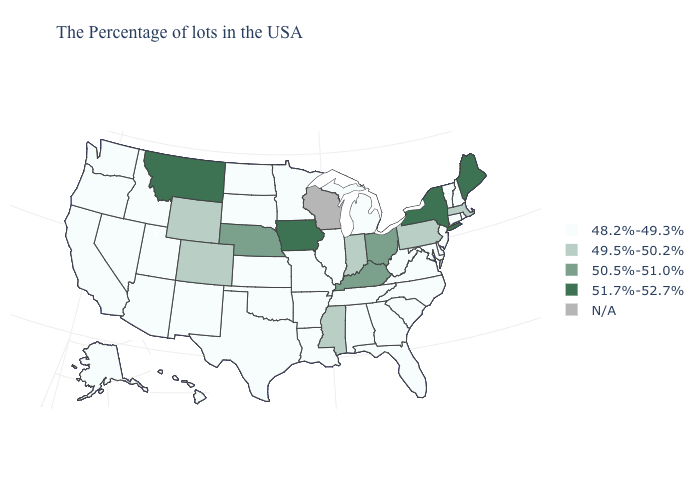Which states have the lowest value in the MidWest?
Keep it brief. Michigan, Illinois, Missouri, Minnesota, Kansas, South Dakota, North Dakota. What is the value of South Dakota?
Be succinct. 48.2%-49.3%. What is the lowest value in states that border Louisiana?
Be succinct. 48.2%-49.3%. Which states have the lowest value in the West?
Keep it brief. New Mexico, Utah, Arizona, Idaho, Nevada, California, Washington, Oregon, Alaska, Hawaii. What is the lowest value in the West?
Concise answer only. 48.2%-49.3%. What is the lowest value in states that border Arkansas?
Keep it brief. 48.2%-49.3%. What is the value of Minnesota?
Short answer required. 48.2%-49.3%. Does Iowa have the highest value in the MidWest?
Write a very short answer. Yes. What is the value of Kentucky?
Answer briefly. 50.5%-51.0%. Does the map have missing data?
Write a very short answer. Yes. What is the value of Illinois?
Quick response, please. 48.2%-49.3%. Among the states that border Minnesota , does Iowa have the highest value?
Quick response, please. Yes. Which states have the highest value in the USA?
Quick response, please. Maine, New York, Iowa, Montana. 